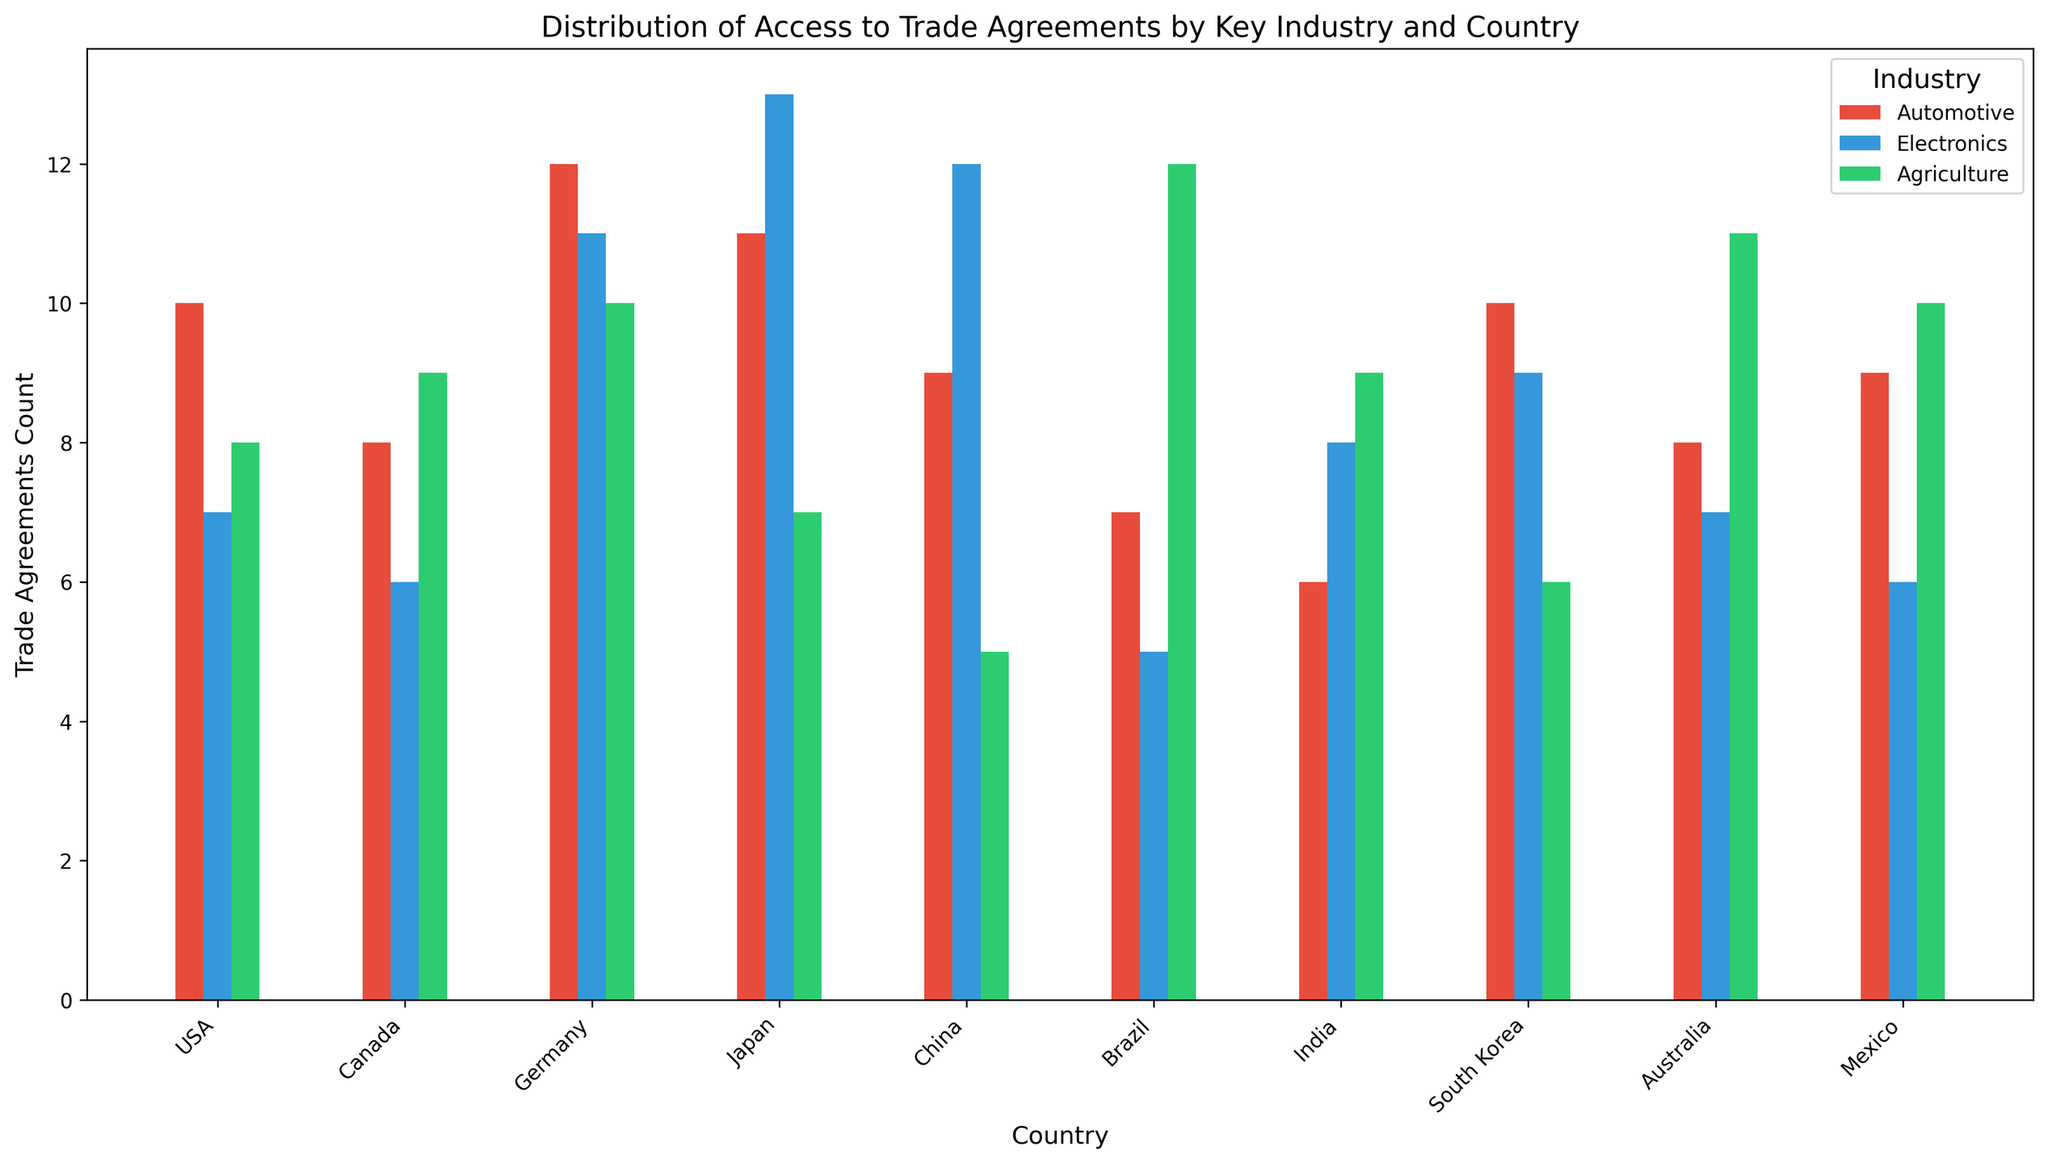What is the total number of trade agreements for the agriculture industry across all countries? Sum the values of the "Trade_Agreements_Count" for the Agriculture industry from all countries: 8 (USA) + 9 (Canada) + 10 (Germany) + 7 (Japan) + 5 (China) + 12 (Brazil) + 9 (India) + 6 (South Korea) + 11 (Australia) + 10 (Mexico) = 87
Answer: 87 Which country has the highest number of trade agreements in the Electronics industry? Compare the trade agreements count for the Electronics industry across all countries: USA (7), Canada (6), Germany (11), Japan (13), China (12), Brazil (5), India (8), South Korea (9), Australia (7), Mexico (6). Japan has the highest count of 13.
Answer: Japan Is the trade agreement count for the Automotive industry in South Korea greater than in China? Compare the trade agreement count in South Korea (10) and China (9). South Korea has more agreements.
Answer: Yes For which industry does Canada have the lowest number of trade agreements? Compare the number of trade agreements in Canada across industries: Automotive (8), Electronics (6), Agriculture (9). Canada has the lowest count in Electronics.
Answer: Electronics Which industry has the most consistent number of trade agreements across all countries? Assess the variation in trade agreements for each industry across countries. The Automotive industry shows less variation compared to Electronics and Agriculture with trade agreements counts not fluctuating as widely (ranging from 6 to 12).
Answer: Automotive What is the average number of trade agreements for the Electronics industry? Calculate the average by summing up the trade agreements counts for Electronics across all countries and divide by the number of countries: (7 + 6 + 11 + 13 + 12 + 5 + 8 + 9 + 7 + 6) / 10 = 8.4
Answer: 8.4 Does any country have the same number of trade agreements for Automotive and Agriculture industries? Compare the trade agreement counts for Automotive and Agriculture industries in each country. No country has the same trade agreements count for these two industries.
Answer: No Which color is used for the bars representing the Agriculture industry in the chart? Identify the color used in the bar chart for the Agriculture industry, which is represented by green color (#2ecc71) as per given color mapping.
Answer: Green By how many agreements does Japan's Electronics industry exceed China's Automotive industry? Subtract the trade agreements count for China's Automotive (9) from Japan's Electronics count (13). The difference is 13 - 9 = 4
Answer: 4 What is the difference in trade agreements count between the highest and lowest countries in the Automotive industry? Identify the highest (Germany: 12) and lowest (India: 6) trade agreements count in the Automotive industry and calculate the difference: 12 - 6 = 6
Answer: 6 